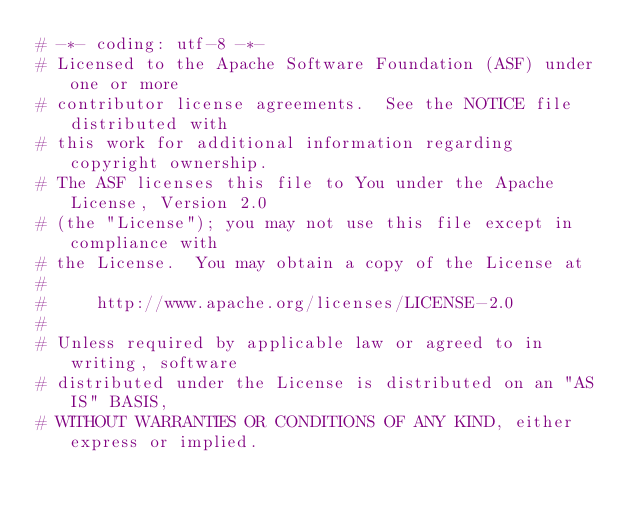Convert code to text. <code><loc_0><loc_0><loc_500><loc_500><_Python_># -*- coding: utf-8 -*-
# Licensed to the Apache Software Foundation (ASF) under one or more
# contributor license agreements.  See the NOTICE file distributed with
# this work for additional information regarding copyright ownership.
# The ASF licenses this file to You under the Apache License, Version 2.0
# (the "License"); you may not use this file except in compliance with
# the License.  You may obtain a copy of the License at
#
#     http://www.apache.org/licenses/LICENSE-2.0
#
# Unless required by applicable law or agreed to in writing, software
# distributed under the License is distributed on an "AS IS" BASIS,
# WITHOUT WARRANTIES OR CONDITIONS OF ANY KIND, either express or implied.</code> 